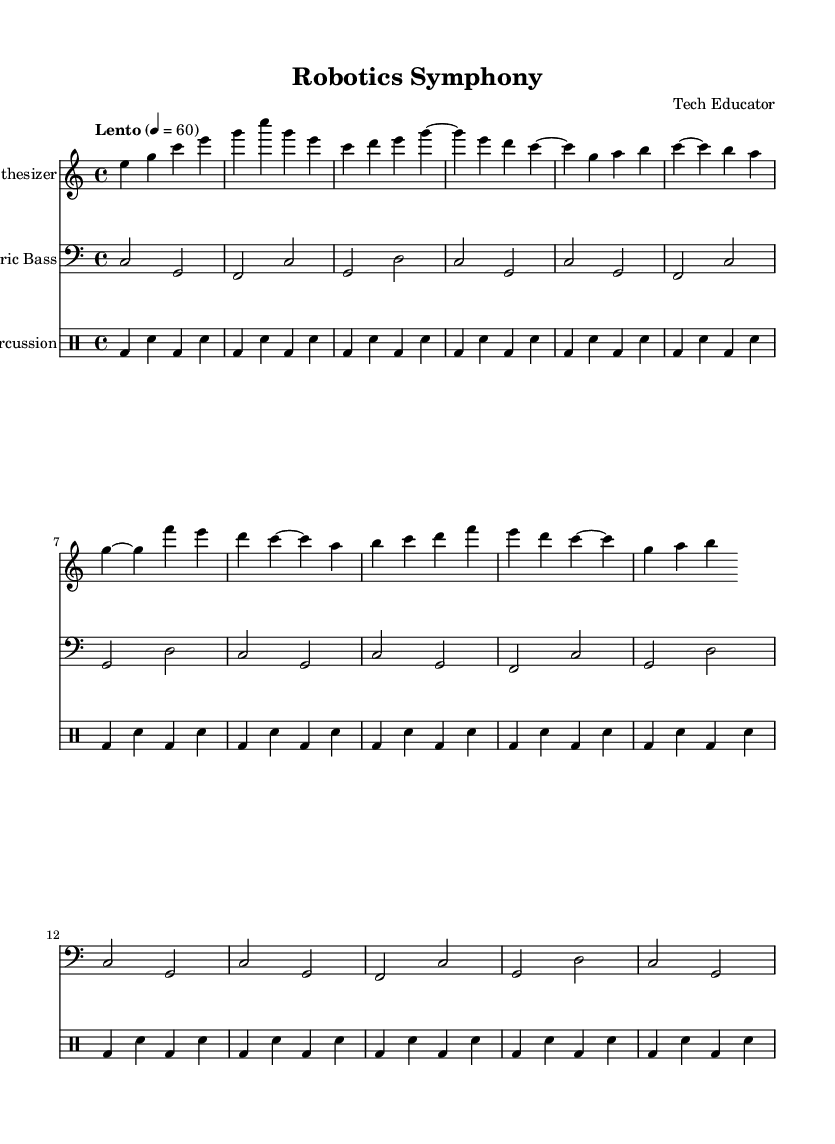What is the key signature of this music? The key signature is C major, which has no sharps or flats.
Answer: C major What is the time signature of this music? The time signature appears as 4/4, indicating four beats per measure.
Answer: 4/4 What is the tempo marking of the piece? The tempo marking is "Lento," suggesting a slow pace, and it indicates a speed of 60 beats per minute.
Answer: Lento How many measures are in Section A? By counting the measures in Section A, which contains two phrases, there are a total of 6 measures.
Answer: 6 What instruments are present in the score? The score includes three instruments: synthesizer, electric bass, and percussion.
Answer: Synthesizer, electric bass, percussion Describe the rhythmic pattern used in the percussion section. The percussion section has a repeating pattern that consists of a bass drum followed by a snare drum for 16 beats.
Answer: Bass drum, snare drum What harmonic role does the electric bass play in the piece? The electric bass provides the harmonic foundation and outlines chords primarily through root notes and their fifths.
Answer: Harmonic foundation 